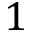Convert formula to latex. <formula><loc_0><loc_0><loc_500><loc_500>1</formula> 